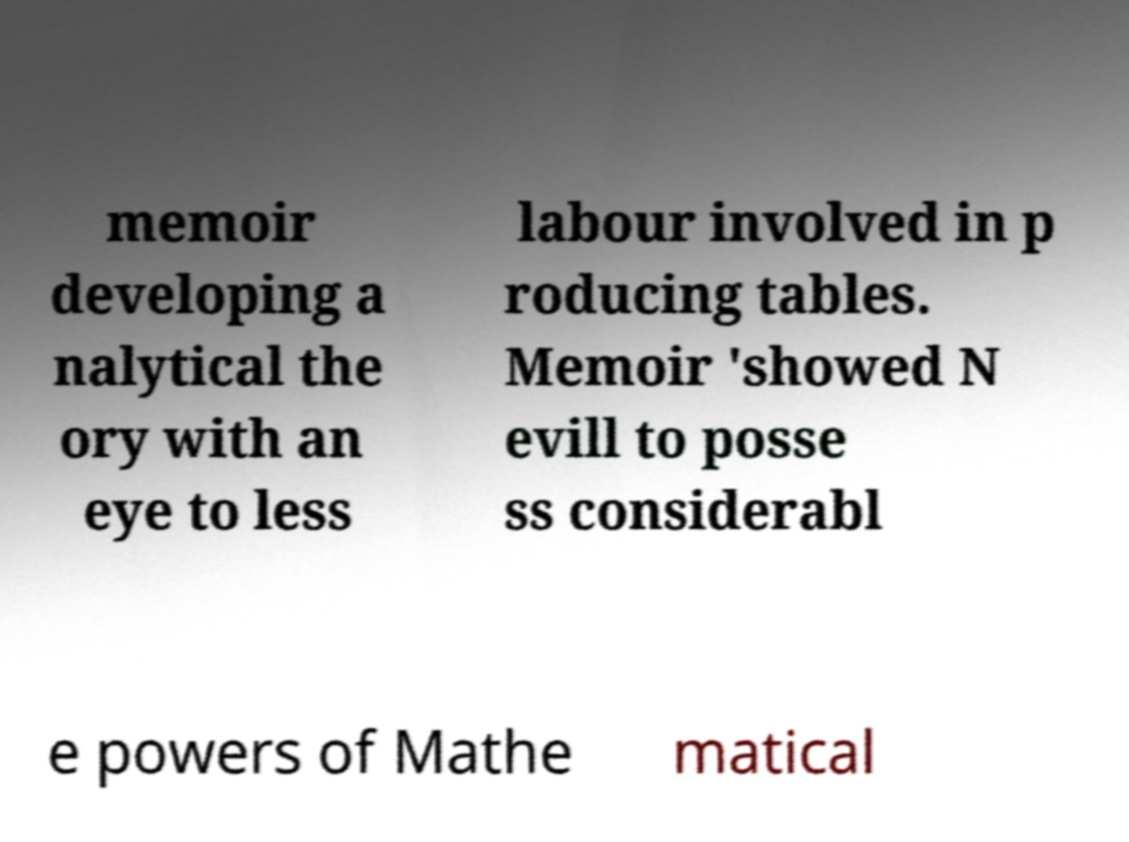Could you assist in decoding the text presented in this image and type it out clearly? memoir developing a nalytical the ory with an eye to less labour involved in p roducing tables. Memoir 'showed N evill to posse ss considerabl e powers of Mathe matical 